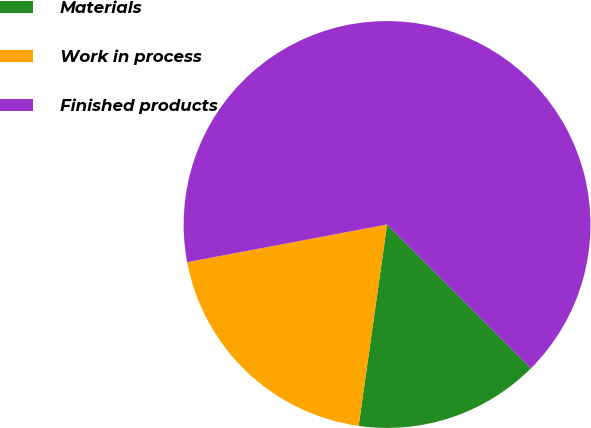Convert chart. <chart><loc_0><loc_0><loc_500><loc_500><pie_chart><fcel>Materials<fcel>Work in process<fcel>Finished products<nl><fcel>14.73%<fcel>19.8%<fcel>65.47%<nl></chart> 